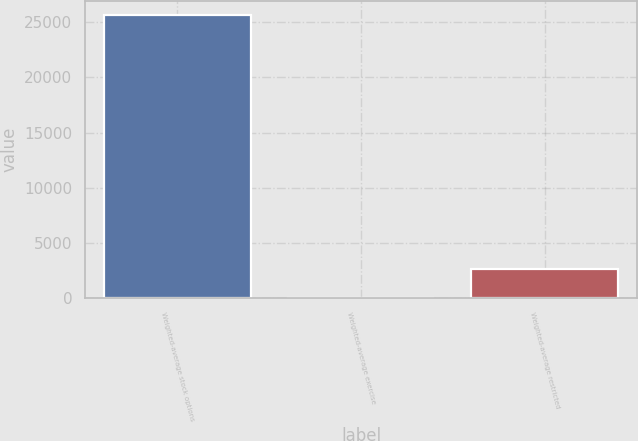Convert chart. <chart><loc_0><loc_0><loc_500><loc_500><bar_chart><fcel>Weighted-average stock options<fcel>Weighted-average exercise<fcel>Weighted-average restricted<nl><fcel>25632<fcel>36.46<fcel>2596.01<nl></chart> 